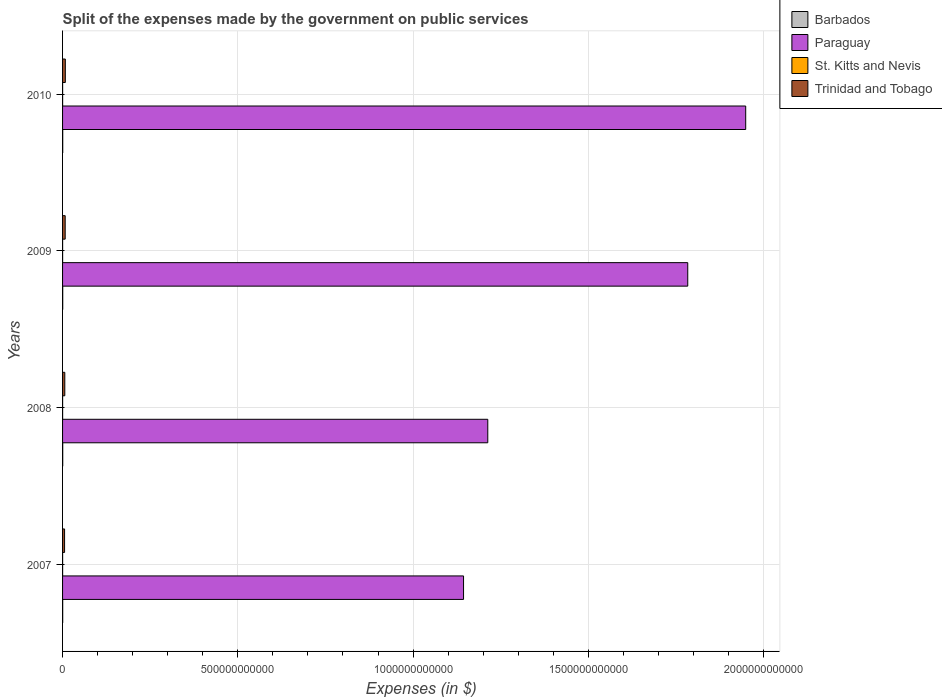How many different coloured bars are there?
Give a very brief answer. 4. How many groups of bars are there?
Give a very brief answer. 4. Are the number of bars per tick equal to the number of legend labels?
Your answer should be very brief. Yes. Are the number of bars on each tick of the Y-axis equal?
Your answer should be very brief. Yes. How many bars are there on the 4th tick from the bottom?
Offer a very short reply. 4. What is the expenses made by the government on public services in Paraguay in 2010?
Ensure brevity in your answer.  1.95e+12. Across all years, what is the maximum expenses made by the government on public services in Barbados?
Offer a very short reply. 4.44e+08. Across all years, what is the minimum expenses made by the government on public services in Barbados?
Offer a very short reply. 3.67e+08. In which year was the expenses made by the government on public services in Trinidad and Tobago maximum?
Provide a succinct answer. 2010. What is the total expenses made by the government on public services in Paraguay in the graph?
Offer a terse response. 6.09e+12. What is the difference between the expenses made by the government on public services in Barbados in 2007 and that in 2008?
Make the answer very short. -6.75e+07. What is the difference between the expenses made by the government on public services in Paraguay in 2010 and the expenses made by the government on public services in Trinidad and Tobago in 2007?
Offer a very short reply. 1.94e+12. What is the average expenses made by the government on public services in Paraguay per year?
Your answer should be very brief. 1.52e+12. In the year 2010, what is the difference between the expenses made by the government on public services in Barbados and expenses made by the government on public services in Trinidad and Tobago?
Offer a terse response. -7.45e+09. What is the ratio of the expenses made by the government on public services in Barbados in 2007 to that in 2009?
Keep it short and to the point. 0.83. Is the expenses made by the government on public services in Barbados in 2008 less than that in 2010?
Your answer should be very brief. Yes. Is the difference between the expenses made by the government on public services in Barbados in 2007 and 2008 greater than the difference between the expenses made by the government on public services in Trinidad and Tobago in 2007 and 2008?
Provide a short and direct response. Yes. What is the difference between the highest and the second highest expenses made by the government on public services in St. Kitts and Nevis?
Keep it short and to the point. 3.20e+06. What is the difference between the highest and the lowest expenses made by the government on public services in St. Kitts and Nevis?
Ensure brevity in your answer.  2.23e+07. In how many years, is the expenses made by the government on public services in Barbados greater than the average expenses made by the government on public services in Barbados taken over all years?
Provide a succinct answer. 3. What does the 4th bar from the top in 2007 represents?
Your response must be concise. Barbados. What does the 4th bar from the bottom in 2007 represents?
Keep it short and to the point. Trinidad and Tobago. Is it the case that in every year, the sum of the expenses made by the government on public services in Barbados and expenses made by the government on public services in Paraguay is greater than the expenses made by the government on public services in Trinidad and Tobago?
Provide a short and direct response. Yes. Are all the bars in the graph horizontal?
Your answer should be compact. Yes. How many years are there in the graph?
Give a very brief answer. 4. What is the difference between two consecutive major ticks on the X-axis?
Offer a very short reply. 5.00e+11. Are the values on the major ticks of X-axis written in scientific E-notation?
Offer a terse response. No. Does the graph contain any zero values?
Offer a very short reply. No. Does the graph contain grids?
Make the answer very short. Yes. Where does the legend appear in the graph?
Give a very brief answer. Top right. How are the legend labels stacked?
Provide a short and direct response. Vertical. What is the title of the graph?
Provide a short and direct response. Split of the expenses made by the government on public services. What is the label or title of the X-axis?
Provide a short and direct response. Expenses (in $). What is the label or title of the Y-axis?
Your answer should be very brief. Years. What is the Expenses (in $) of Barbados in 2007?
Give a very brief answer. 3.67e+08. What is the Expenses (in $) in Paraguay in 2007?
Your response must be concise. 1.14e+12. What is the Expenses (in $) in St. Kitts and Nevis in 2007?
Keep it short and to the point. 1.40e+08. What is the Expenses (in $) in Trinidad and Tobago in 2007?
Offer a terse response. 5.72e+09. What is the Expenses (in $) in Barbados in 2008?
Provide a short and direct response. 4.35e+08. What is the Expenses (in $) in Paraguay in 2008?
Give a very brief answer. 1.21e+12. What is the Expenses (in $) in St. Kitts and Nevis in 2008?
Give a very brief answer. 1.37e+08. What is the Expenses (in $) in Trinidad and Tobago in 2008?
Offer a terse response. 6.37e+09. What is the Expenses (in $) of Barbados in 2009?
Ensure brevity in your answer.  4.44e+08. What is the Expenses (in $) in Paraguay in 2009?
Keep it short and to the point. 1.78e+12. What is the Expenses (in $) in St. Kitts and Nevis in 2009?
Ensure brevity in your answer.  1.29e+08. What is the Expenses (in $) in Trinidad and Tobago in 2009?
Ensure brevity in your answer.  7.48e+09. What is the Expenses (in $) of Barbados in 2010?
Ensure brevity in your answer.  4.35e+08. What is the Expenses (in $) in Paraguay in 2010?
Your answer should be very brief. 1.95e+12. What is the Expenses (in $) of St. Kitts and Nevis in 2010?
Offer a very short reply. 1.18e+08. What is the Expenses (in $) in Trinidad and Tobago in 2010?
Give a very brief answer. 7.89e+09. Across all years, what is the maximum Expenses (in $) in Barbados?
Make the answer very short. 4.44e+08. Across all years, what is the maximum Expenses (in $) of Paraguay?
Give a very brief answer. 1.95e+12. Across all years, what is the maximum Expenses (in $) of St. Kitts and Nevis?
Ensure brevity in your answer.  1.40e+08. Across all years, what is the maximum Expenses (in $) of Trinidad and Tobago?
Provide a succinct answer. 7.89e+09. Across all years, what is the minimum Expenses (in $) of Barbados?
Your answer should be very brief. 3.67e+08. Across all years, what is the minimum Expenses (in $) in Paraguay?
Provide a short and direct response. 1.14e+12. Across all years, what is the minimum Expenses (in $) in St. Kitts and Nevis?
Make the answer very short. 1.18e+08. Across all years, what is the minimum Expenses (in $) in Trinidad and Tobago?
Offer a very short reply. 5.72e+09. What is the total Expenses (in $) in Barbados in the graph?
Your response must be concise. 1.68e+09. What is the total Expenses (in $) in Paraguay in the graph?
Ensure brevity in your answer.  6.09e+12. What is the total Expenses (in $) of St. Kitts and Nevis in the graph?
Offer a terse response. 5.25e+08. What is the total Expenses (in $) in Trinidad and Tobago in the graph?
Ensure brevity in your answer.  2.75e+1. What is the difference between the Expenses (in $) of Barbados in 2007 and that in 2008?
Offer a terse response. -6.75e+07. What is the difference between the Expenses (in $) of Paraguay in 2007 and that in 2008?
Give a very brief answer. -6.91e+1. What is the difference between the Expenses (in $) of St. Kitts and Nevis in 2007 and that in 2008?
Your response must be concise. 3.20e+06. What is the difference between the Expenses (in $) in Trinidad and Tobago in 2007 and that in 2008?
Keep it short and to the point. -6.47e+08. What is the difference between the Expenses (in $) of Barbados in 2007 and that in 2009?
Provide a succinct answer. -7.74e+07. What is the difference between the Expenses (in $) of Paraguay in 2007 and that in 2009?
Your answer should be very brief. -6.40e+11. What is the difference between the Expenses (in $) in St. Kitts and Nevis in 2007 and that in 2009?
Offer a very short reply. 1.13e+07. What is the difference between the Expenses (in $) of Trinidad and Tobago in 2007 and that in 2009?
Provide a short and direct response. -1.76e+09. What is the difference between the Expenses (in $) in Barbados in 2007 and that in 2010?
Provide a succinct answer. -6.83e+07. What is the difference between the Expenses (in $) in Paraguay in 2007 and that in 2010?
Provide a succinct answer. -8.05e+11. What is the difference between the Expenses (in $) of St. Kitts and Nevis in 2007 and that in 2010?
Your answer should be compact. 2.23e+07. What is the difference between the Expenses (in $) of Trinidad and Tobago in 2007 and that in 2010?
Give a very brief answer. -2.17e+09. What is the difference between the Expenses (in $) in Barbados in 2008 and that in 2009?
Provide a succinct answer. -9.82e+06. What is the difference between the Expenses (in $) of Paraguay in 2008 and that in 2009?
Offer a very short reply. -5.70e+11. What is the difference between the Expenses (in $) of St. Kitts and Nevis in 2008 and that in 2009?
Your response must be concise. 8.10e+06. What is the difference between the Expenses (in $) of Trinidad and Tobago in 2008 and that in 2009?
Offer a terse response. -1.12e+09. What is the difference between the Expenses (in $) in Barbados in 2008 and that in 2010?
Provide a short and direct response. -7.51e+05. What is the difference between the Expenses (in $) in Paraguay in 2008 and that in 2010?
Provide a short and direct response. -7.36e+11. What is the difference between the Expenses (in $) in St. Kitts and Nevis in 2008 and that in 2010?
Keep it short and to the point. 1.91e+07. What is the difference between the Expenses (in $) in Trinidad and Tobago in 2008 and that in 2010?
Offer a very short reply. -1.52e+09. What is the difference between the Expenses (in $) in Barbados in 2009 and that in 2010?
Ensure brevity in your answer.  9.07e+06. What is the difference between the Expenses (in $) in Paraguay in 2009 and that in 2010?
Provide a short and direct response. -1.65e+11. What is the difference between the Expenses (in $) in St. Kitts and Nevis in 2009 and that in 2010?
Ensure brevity in your answer.  1.10e+07. What is the difference between the Expenses (in $) of Trinidad and Tobago in 2009 and that in 2010?
Your answer should be very brief. -4.02e+08. What is the difference between the Expenses (in $) in Barbados in 2007 and the Expenses (in $) in Paraguay in 2008?
Keep it short and to the point. -1.21e+12. What is the difference between the Expenses (in $) in Barbados in 2007 and the Expenses (in $) in St. Kitts and Nevis in 2008?
Give a very brief answer. 2.30e+08. What is the difference between the Expenses (in $) in Barbados in 2007 and the Expenses (in $) in Trinidad and Tobago in 2008?
Offer a very short reply. -6.00e+09. What is the difference between the Expenses (in $) of Paraguay in 2007 and the Expenses (in $) of St. Kitts and Nevis in 2008?
Your answer should be compact. 1.14e+12. What is the difference between the Expenses (in $) of Paraguay in 2007 and the Expenses (in $) of Trinidad and Tobago in 2008?
Your answer should be very brief. 1.14e+12. What is the difference between the Expenses (in $) in St. Kitts and Nevis in 2007 and the Expenses (in $) in Trinidad and Tobago in 2008?
Your answer should be very brief. -6.23e+09. What is the difference between the Expenses (in $) of Barbados in 2007 and the Expenses (in $) of Paraguay in 2009?
Keep it short and to the point. -1.78e+12. What is the difference between the Expenses (in $) in Barbados in 2007 and the Expenses (in $) in St. Kitts and Nevis in 2009?
Offer a terse response. 2.38e+08. What is the difference between the Expenses (in $) of Barbados in 2007 and the Expenses (in $) of Trinidad and Tobago in 2009?
Provide a short and direct response. -7.12e+09. What is the difference between the Expenses (in $) in Paraguay in 2007 and the Expenses (in $) in St. Kitts and Nevis in 2009?
Provide a succinct answer. 1.14e+12. What is the difference between the Expenses (in $) of Paraguay in 2007 and the Expenses (in $) of Trinidad and Tobago in 2009?
Offer a terse response. 1.14e+12. What is the difference between the Expenses (in $) in St. Kitts and Nevis in 2007 and the Expenses (in $) in Trinidad and Tobago in 2009?
Ensure brevity in your answer.  -7.34e+09. What is the difference between the Expenses (in $) of Barbados in 2007 and the Expenses (in $) of Paraguay in 2010?
Your answer should be very brief. -1.95e+12. What is the difference between the Expenses (in $) in Barbados in 2007 and the Expenses (in $) in St. Kitts and Nevis in 2010?
Your answer should be very brief. 2.49e+08. What is the difference between the Expenses (in $) of Barbados in 2007 and the Expenses (in $) of Trinidad and Tobago in 2010?
Offer a very short reply. -7.52e+09. What is the difference between the Expenses (in $) in Paraguay in 2007 and the Expenses (in $) in St. Kitts and Nevis in 2010?
Offer a terse response. 1.14e+12. What is the difference between the Expenses (in $) in Paraguay in 2007 and the Expenses (in $) in Trinidad and Tobago in 2010?
Keep it short and to the point. 1.14e+12. What is the difference between the Expenses (in $) of St. Kitts and Nevis in 2007 and the Expenses (in $) of Trinidad and Tobago in 2010?
Provide a short and direct response. -7.75e+09. What is the difference between the Expenses (in $) of Barbados in 2008 and the Expenses (in $) of Paraguay in 2009?
Offer a terse response. -1.78e+12. What is the difference between the Expenses (in $) in Barbados in 2008 and the Expenses (in $) in St. Kitts and Nevis in 2009?
Offer a terse response. 3.05e+08. What is the difference between the Expenses (in $) of Barbados in 2008 and the Expenses (in $) of Trinidad and Tobago in 2009?
Provide a succinct answer. -7.05e+09. What is the difference between the Expenses (in $) of Paraguay in 2008 and the Expenses (in $) of St. Kitts and Nevis in 2009?
Make the answer very short. 1.21e+12. What is the difference between the Expenses (in $) in Paraguay in 2008 and the Expenses (in $) in Trinidad and Tobago in 2009?
Ensure brevity in your answer.  1.21e+12. What is the difference between the Expenses (in $) of St. Kitts and Nevis in 2008 and the Expenses (in $) of Trinidad and Tobago in 2009?
Provide a short and direct response. -7.35e+09. What is the difference between the Expenses (in $) in Barbados in 2008 and the Expenses (in $) in Paraguay in 2010?
Offer a terse response. -1.95e+12. What is the difference between the Expenses (in $) in Barbados in 2008 and the Expenses (in $) in St. Kitts and Nevis in 2010?
Your response must be concise. 3.16e+08. What is the difference between the Expenses (in $) of Barbados in 2008 and the Expenses (in $) of Trinidad and Tobago in 2010?
Provide a short and direct response. -7.45e+09. What is the difference between the Expenses (in $) of Paraguay in 2008 and the Expenses (in $) of St. Kitts and Nevis in 2010?
Ensure brevity in your answer.  1.21e+12. What is the difference between the Expenses (in $) in Paraguay in 2008 and the Expenses (in $) in Trinidad and Tobago in 2010?
Give a very brief answer. 1.21e+12. What is the difference between the Expenses (in $) in St. Kitts and Nevis in 2008 and the Expenses (in $) in Trinidad and Tobago in 2010?
Give a very brief answer. -7.75e+09. What is the difference between the Expenses (in $) in Barbados in 2009 and the Expenses (in $) in Paraguay in 2010?
Offer a very short reply. -1.95e+12. What is the difference between the Expenses (in $) of Barbados in 2009 and the Expenses (in $) of St. Kitts and Nevis in 2010?
Make the answer very short. 3.26e+08. What is the difference between the Expenses (in $) of Barbados in 2009 and the Expenses (in $) of Trinidad and Tobago in 2010?
Ensure brevity in your answer.  -7.44e+09. What is the difference between the Expenses (in $) of Paraguay in 2009 and the Expenses (in $) of St. Kitts and Nevis in 2010?
Keep it short and to the point. 1.78e+12. What is the difference between the Expenses (in $) of Paraguay in 2009 and the Expenses (in $) of Trinidad and Tobago in 2010?
Keep it short and to the point. 1.78e+12. What is the difference between the Expenses (in $) in St. Kitts and Nevis in 2009 and the Expenses (in $) in Trinidad and Tobago in 2010?
Provide a short and direct response. -7.76e+09. What is the average Expenses (in $) of Barbados per year?
Give a very brief answer. 4.20e+08. What is the average Expenses (in $) of Paraguay per year?
Provide a succinct answer. 1.52e+12. What is the average Expenses (in $) of St. Kitts and Nevis per year?
Provide a short and direct response. 1.31e+08. What is the average Expenses (in $) of Trinidad and Tobago per year?
Make the answer very short. 6.86e+09. In the year 2007, what is the difference between the Expenses (in $) in Barbados and Expenses (in $) in Paraguay?
Provide a short and direct response. -1.14e+12. In the year 2007, what is the difference between the Expenses (in $) of Barbados and Expenses (in $) of St. Kitts and Nevis?
Provide a short and direct response. 2.27e+08. In the year 2007, what is the difference between the Expenses (in $) in Barbados and Expenses (in $) in Trinidad and Tobago?
Offer a terse response. -5.35e+09. In the year 2007, what is the difference between the Expenses (in $) of Paraguay and Expenses (in $) of St. Kitts and Nevis?
Your answer should be very brief. 1.14e+12. In the year 2007, what is the difference between the Expenses (in $) of Paraguay and Expenses (in $) of Trinidad and Tobago?
Your answer should be very brief. 1.14e+12. In the year 2007, what is the difference between the Expenses (in $) of St. Kitts and Nevis and Expenses (in $) of Trinidad and Tobago?
Offer a terse response. -5.58e+09. In the year 2008, what is the difference between the Expenses (in $) in Barbados and Expenses (in $) in Paraguay?
Offer a terse response. -1.21e+12. In the year 2008, what is the difference between the Expenses (in $) in Barbados and Expenses (in $) in St. Kitts and Nevis?
Provide a short and direct response. 2.97e+08. In the year 2008, what is the difference between the Expenses (in $) of Barbados and Expenses (in $) of Trinidad and Tobago?
Ensure brevity in your answer.  -5.93e+09. In the year 2008, what is the difference between the Expenses (in $) of Paraguay and Expenses (in $) of St. Kitts and Nevis?
Keep it short and to the point. 1.21e+12. In the year 2008, what is the difference between the Expenses (in $) in Paraguay and Expenses (in $) in Trinidad and Tobago?
Make the answer very short. 1.21e+12. In the year 2008, what is the difference between the Expenses (in $) in St. Kitts and Nevis and Expenses (in $) in Trinidad and Tobago?
Your response must be concise. -6.23e+09. In the year 2009, what is the difference between the Expenses (in $) in Barbados and Expenses (in $) in Paraguay?
Ensure brevity in your answer.  -1.78e+12. In the year 2009, what is the difference between the Expenses (in $) of Barbados and Expenses (in $) of St. Kitts and Nevis?
Your answer should be very brief. 3.15e+08. In the year 2009, what is the difference between the Expenses (in $) of Barbados and Expenses (in $) of Trinidad and Tobago?
Provide a short and direct response. -7.04e+09. In the year 2009, what is the difference between the Expenses (in $) in Paraguay and Expenses (in $) in St. Kitts and Nevis?
Provide a succinct answer. 1.78e+12. In the year 2009, what is the difference between the Expenses (in $) in Paraguay and Expenses (in $) in Trinidad and Tobago?
Provide a succinct answer. 1.78e+12. In the year 2009, what is the difference between the Expenses (in $) of St. Kitts and Nevis and Expenses (in $) of Trinidad and Tobago?
Your answer should be very brief. -7.36e+09. In the year 2010, what is the difference between the Expenses (in $) in Barbados and Expenses (in $) in Paraguay?
Give a very brief answer. -1.95e+12. In the year 2010, what is the difference between the Expenses (in $) in Barbados and Expenses (in $) in St. Kitts and Nevis?
Your response must be concise. 3.17e+08. In the year 2010, what is the difference between the Expenses (in $) in Barbados and Expenses (in $) in Trinidad and Tobago?
Your response must be concise. -7.45e+09. In the year 2010, what is the difference between the Expenses (in $) of Paraguay and Expenses (in $) of St. Kitts and Nevis?
Offer a very short reply. 1.95e+12. In the year 2010, what is the difference between the Expenses (in $) of Paraguay and Expenses (in $) of Trinidad and Tobago?
Your answer should be compact. 1.94e+12. In the year 2010, what is the difference between the Expenses (in $) in St. Kitts and Nevis and Expenses (in $) in Trinidad and Tobago?
Ensure brevity in your answer.  -7.77e+09. What is the ratio of the Expenses (in $) in Barbados in 2007 to that in 2008?
Provide a succinct answer. 0.84. What is the ratio of the Expenses (in $) in Paraguay in 2007 to that in 2008?
Offer a terse response. 0.94. What is the ratio of the Expenses (in $) in St. Kitts and Nevis in 2007 to that in 2008?
Give a very brief answer. 1.02. What is the ratio of the Expenses (in $) of Trinidad and Tobago in 2007 to that in 2008?
Keep it short and to the point. 0.9. What is the ratio of the Expenses (in $) of Barbados in 2007 to that in 2009?
Your answer should be compact. 0.83. What is the ratio of the Expenses (in $) of Paraguay in 2007 to that in 2009?
Provide a succinct answer. 0.64. What is the ratio of the Expenses (in $) in St. Kitts and Nevis in 2007 to that in 2009?
Give a very brief answer. 1.09. What is the ratio of the Expenses (in $) of Trinidad and Tobago in 2007 to that in 2009?
Make the answer very short. 0.76. What is the ratio of the Expenses (in $) of Barbados in 2007 to that in 2010?
Make the answer very short. 0.84. What is the ratio of the Expenses (in $) in Paraguay in 2007 to that in 2010?
Keep it short and to the point. 0.59. What is the ratio of the Expenses (in $) of St. Kitts and Nevis in 2007 to that in 2010?
Provide a succinct answer. 1.19. What is the ratio of the Expenses (in $) of Trinidad and Tobago in 2007 to that in 2010?
Offer a very short reply. 0.73. What is the ratio of the Expenses (in $) of Barbados in 2008 to that in 2009?
Make the answer very short. 0.98. What is the ratio of the Expenses (in $) in Paraguay in 2008 to that in 2009?
Offer a very short reply. 0.68. What is the ratio of the Expenses (in $) of St. Kitts and Nevis in 2008 to that in 2009?
Offer a very short reply. 1.06. What is the ratio of the Expenses (in $) of Trinidad and Tobago in 2008 to that in 2009?
Offer a very short reply. 0.85. What is the ratio of the Expenses (in $) in Paraguay in 2008 to that in 2010?
Make the answer very short. 0.62. What is the ratio of the Expenses (in $) of St. Kitts and Nevis in 2008 to that in 2010?
Give a very brief answer. 1.16. What is the ratio of the Expenses (in $) of Trinidad and Tobago in 2008 to that in 2010?
Offer a very short reply. 0.81. What is the ratio of the Expenses (in $) of Barbados in 2009 to that in 2010?
Keep it short and to the point. 1.02. What is the ratio of the Expenses (in $) of Paraguay in 2009 to that in 2010?
Your response must be concise. 0.92. What is the ratio of the Expenses (in $) of St. Kitts and Nevis in 2009 to that in 2010?
Keep it short and to the point. 1.09. What is the ratio of the Expenses (in $) in Trinidad and Tobago in 2009 to that in 2010?
Make the answer very short. 0.95. What is the difference between the highest and the second highest Expenses (in $) of Barbados?
Keep it short and to the point. 9.07e+06. What is the difference between the highest and the second highest Expenses (in $) of Paraguay?
Make the answer very short. 1.65e+11. What is the difference between the highest and the second highest Expenses (in $) in St. Kitts and Nevis?
Offer a terse response. 3.20e+06. What is the difference between the highest and the second highest Expenses (in $) in Trinidad and Tobago?
Your answer should be compact. 4.02e+08. What is the difference between the highest and the lowest Expenses (in $) in Barbados?
Your answer should be very brief. 7.74e+07. What is the difference between the highest and the lowest Expenses (in $) of Paraguay?
Your response must be concise. 8.05e+11. What is the difference between the highest and the lowest Expenses (in $) in St. Kitts and Nevis?
Offer a very short reply. 2.23e+07. What is the difference between the highest and the lowest Expenses (in $) in Trinidad and Tobago?
Provide a succinct answer. 2.17e+09. 